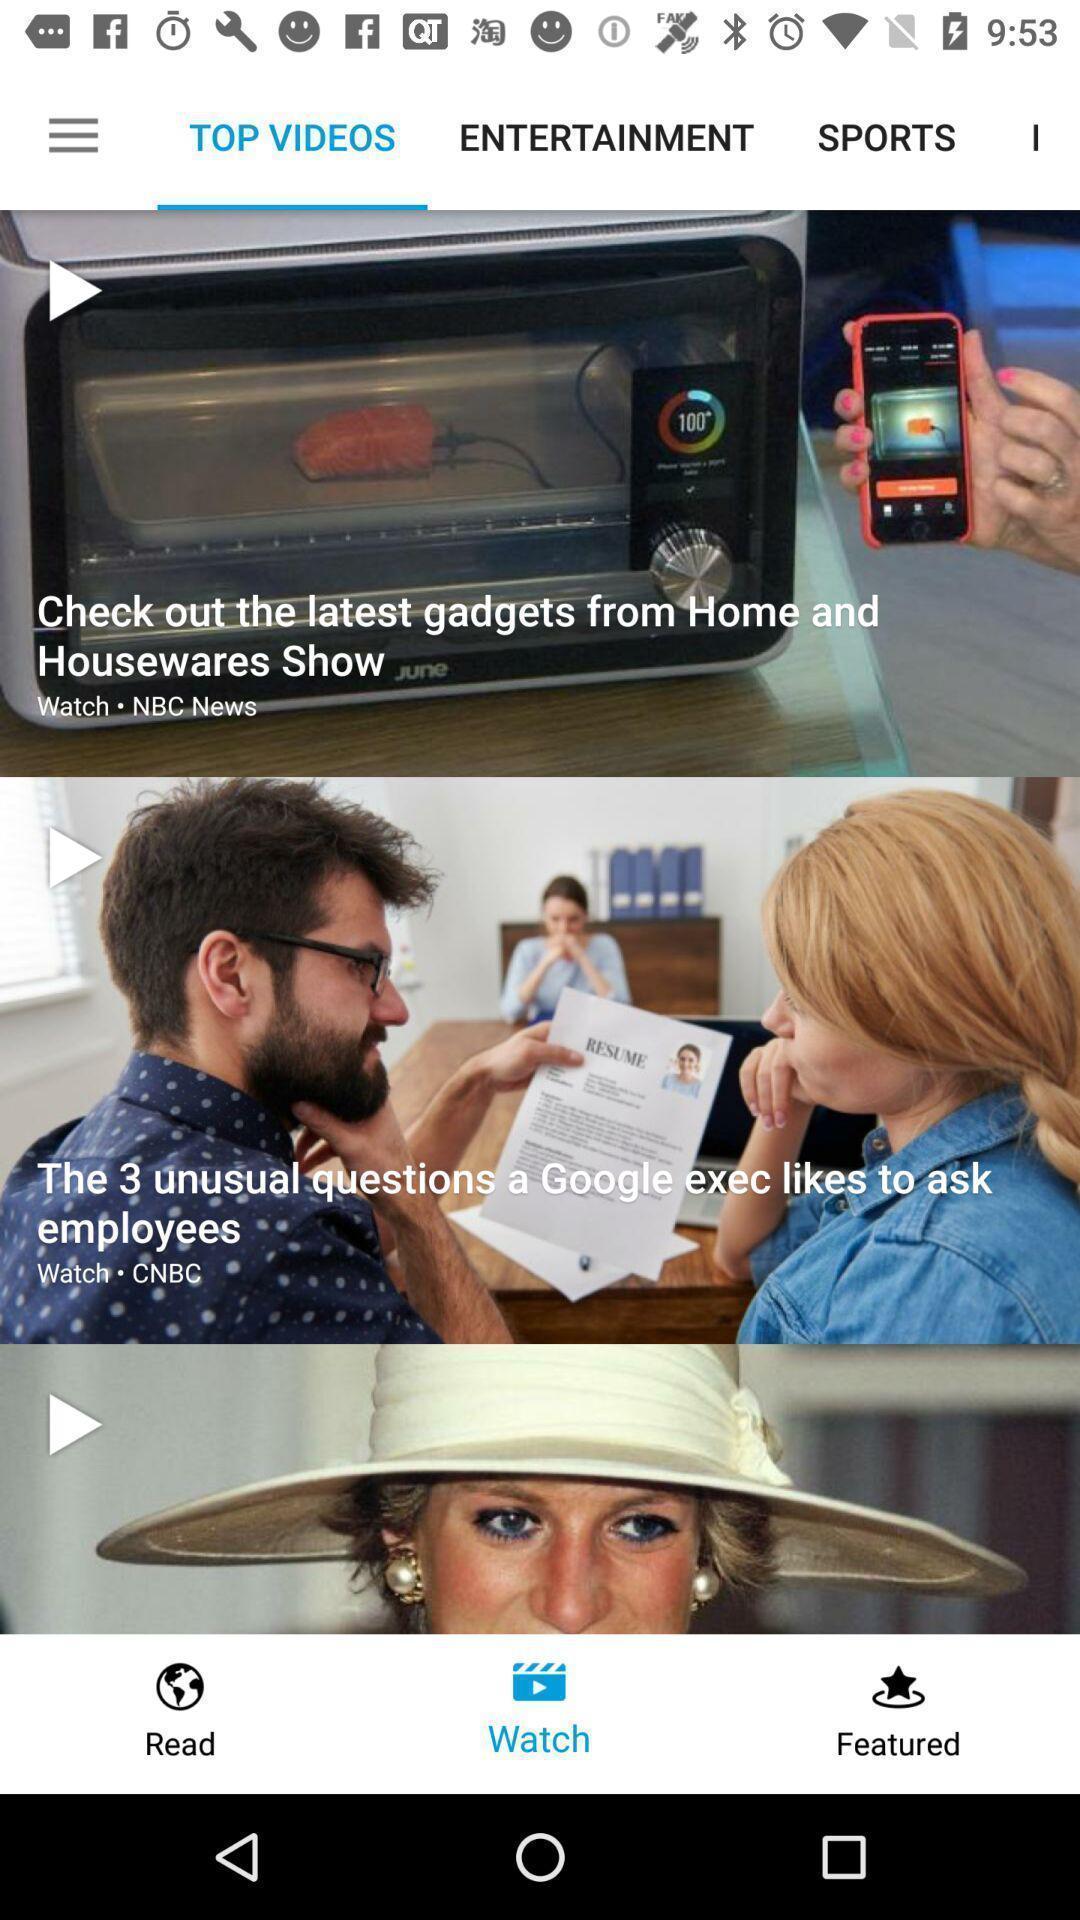What can you discern from this picture? Page showing multiple videos on app. 